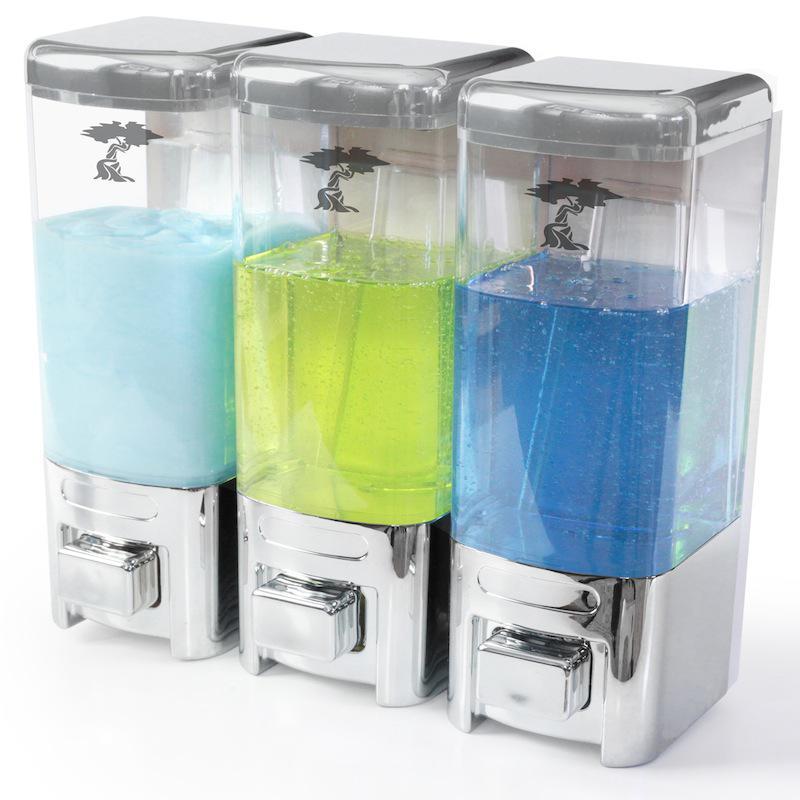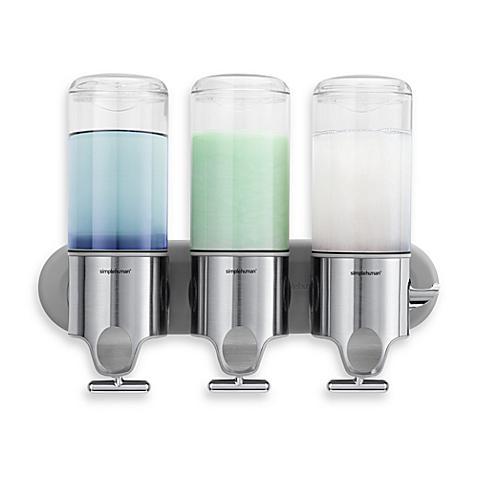The first image is the image on the left, the second image is the image on the right. Considering the images on both sides, is "There are three dispensers filled with substances in each of the images." valid? Answer yes or no. Yes. The first image is the image on the left, the second image is the image on the right. For the images shown, is this caption "Each image shows three side-by-side dispensers, with at least one containing a bluish substance." true? Answer yes or no. Yes. 